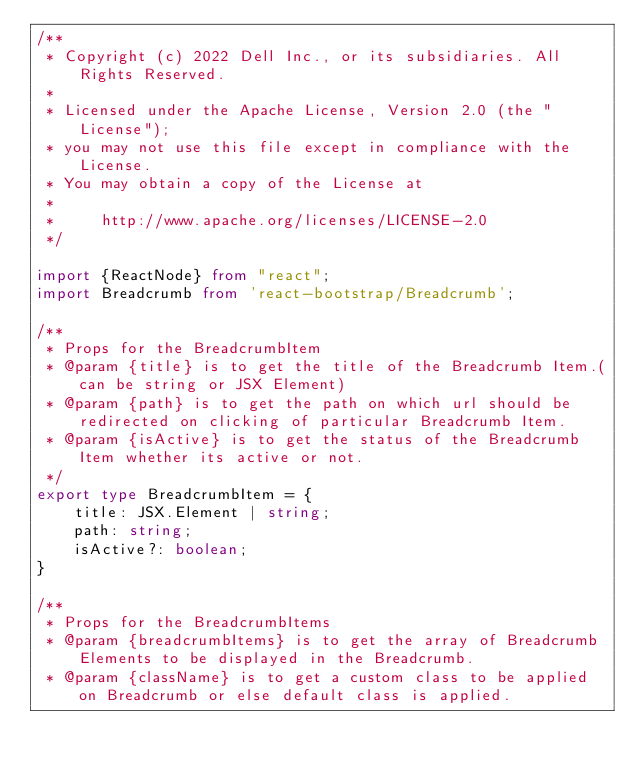<code> <loc_0><loc_0><loc_500><loc_500><_TypeScript_>/**
 * Copyright (c) 2022 Dell Inc., or its subsidiaries. All Rights Reserved.
 *
 * Licensed under the Apache License, Version 2.0 (the "License");
 * you may not use this file except in compliance with the License.
 * You may obtain a copy of the License at
 *
 *     http://www.apache.org/licenses/LICENSE-2.0
 */

import {ReactNode} from "react";
import Breadcrumb from 'react-bootstrap/Breadcrumb';

/**
 * Props for the BreadcrumbItem
 * @param {title} is to get the title of the Breadcrumb Item.(can be string or JSX Element)
 * @param {path} is to get the path on which url should be redirected on clicking of particular Breadcrumb Item.
 * @param {isActive} is to get the status of the Breadcrumb Item whether its active or not.
 */
export type BreadcrumbItem = {
    title: JSX.Element | string;
    path: string;
    isActive?: boolean;
}

/**
 * Props for the BreadcrumbItems
 * @param {breadcrumbItems} is to get the array of Breadcrumb Elements to be displayed in the Breadcrumb.
 * @param {className} is to get a custom class to be applied on Breadcrumb or else default class is applied.</code> 